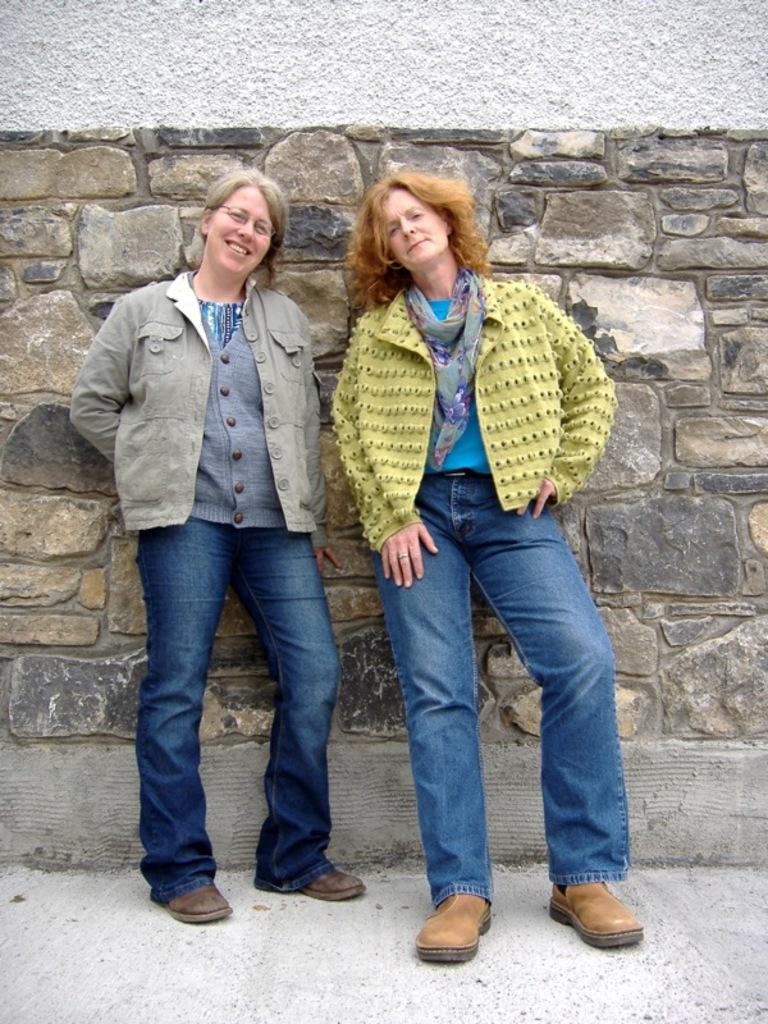How many women are in the image? There are two women in the image. What is the facial expression of the woman on the left side? The woman on the left side is smiling. What can be seen in the background of the image? There is a wall in the background of the image. What type of clothing are the women wearing on their upper bodies? Both women are wearing jackets. What type of clothing are the women wearing on their lower bodies? Both women are wearing jeans. What type of footwear are the women wearing? Both women are wearing footwear. What type of organization does the snake belong to in the image? There is no snake present in the image, so it cannot be determined which organization it might belong to. 